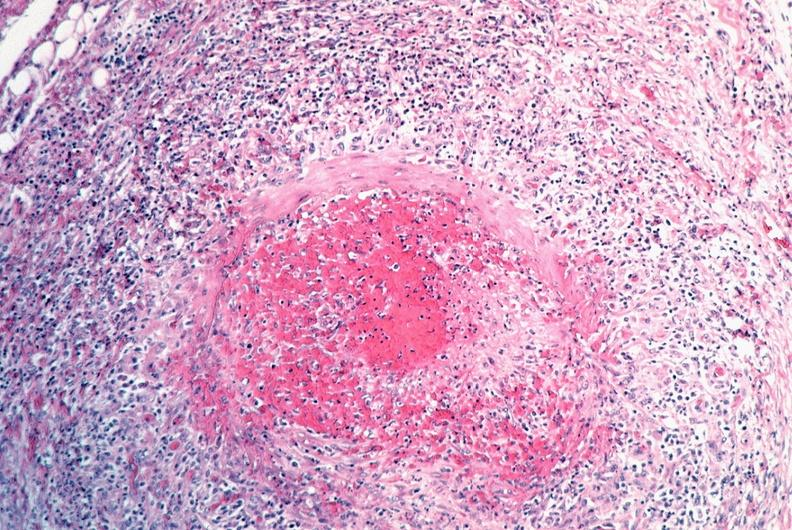s vasculature present?
Answer the question using a single word or phrase. Yes 